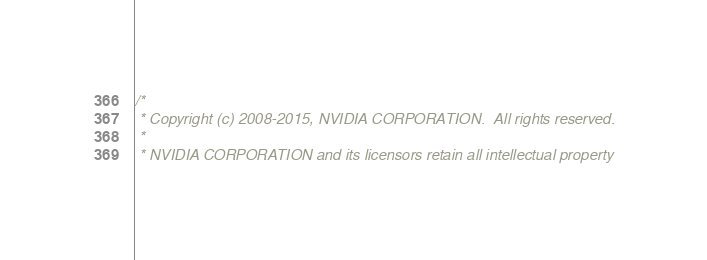<code> <loc_0><loc_0><loc_500><loc_500><_C++_>/*
 * Copyright (c) 2008-2015, NVIDIA CORPORATION.  All rights reserved.
 *
 * NVIDIA CORPORATION and its licensors retain all intellectual property</code> 